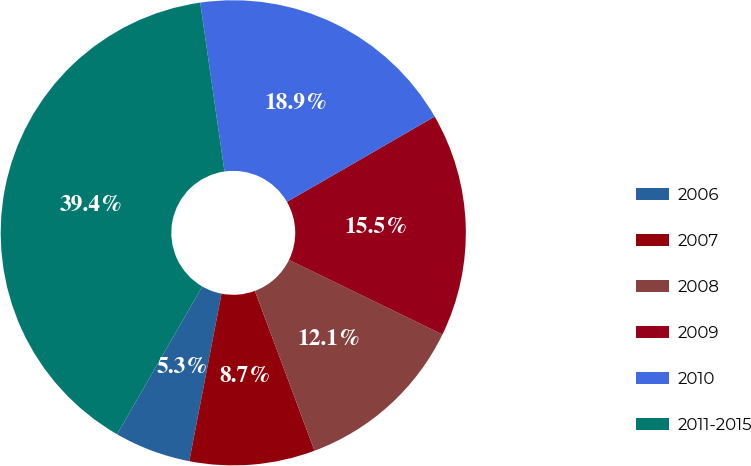Convert chart to OTSL. <chart><loc_0><loc_0><loc_500><loc_500><pie_chart><fcel>2006<fcel>2007<fcel>2008<fcel>2009<fcel>2010<fcel>2011-2015<nl><fcel>5.3%<fcel>8.71%<fcel>12.12%<fcel>15.53%<fcel>18.94%<fcel>39.4%<nl></chart> 